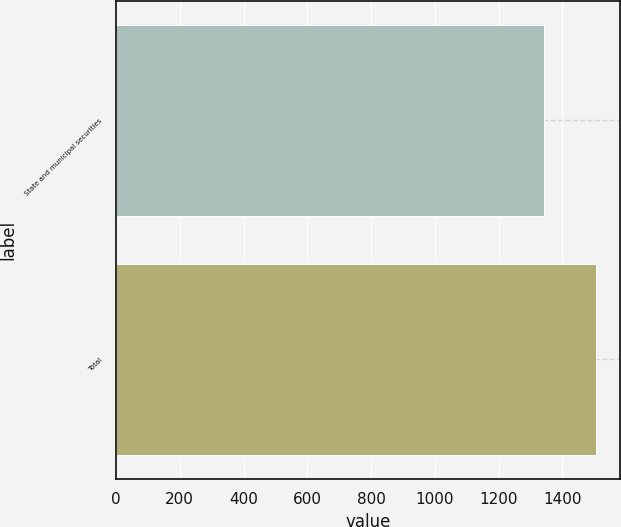Convert chart to OTSL. <chart><loc_0><loc_0><loc_500><loc_500><bar_chart><fcel>State and municipal securities<fcel>Total<nl><fcel>1344<fcel>1507<nl></chart> 